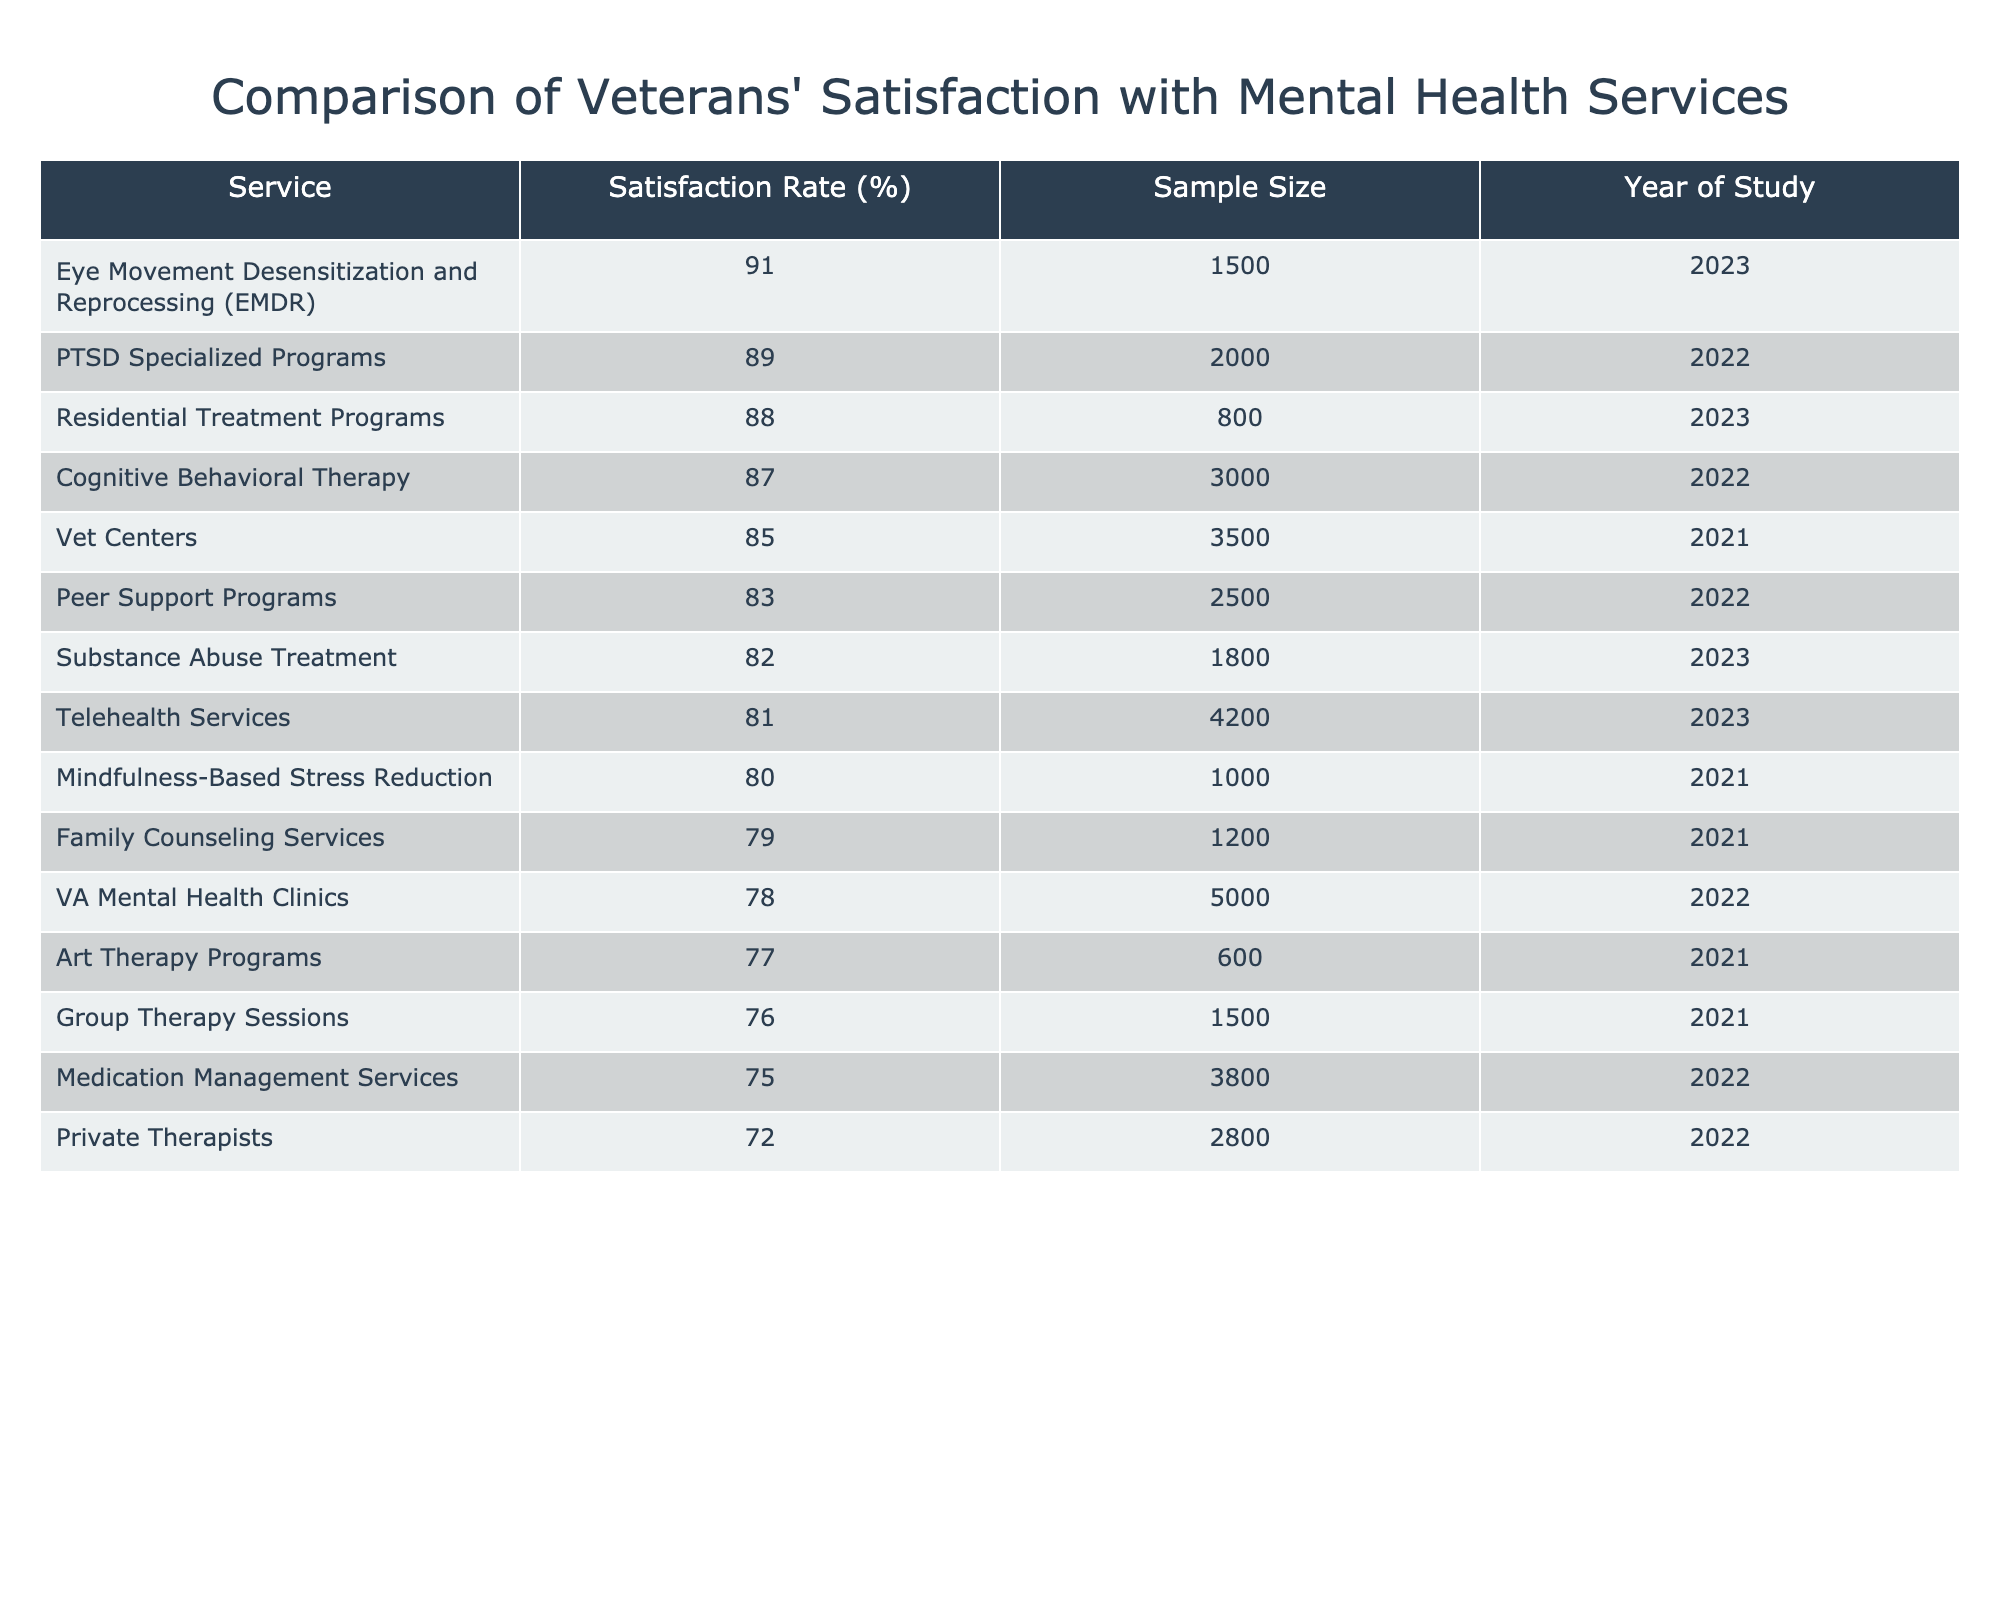What is the satisfaction rate for VA Mental Health Clinics? The satisfaction rate for VA Mental Health Clinics is listed directly in the table under the Satisfaction Rate (%) column, which shows 78%.
Answer: 78% Which mental health service has the highest satisfaction rate? Looking through the Satisfaction Rate (%) column, the highest value is 91%, which corresponds to Eye Movement Desensitization and Reprocessing (EMDR).
Answer: EMDR What is the average satisfaction rate for services with a sample size of 2000 or more? First, we need to identify the services with a sample size of 2000 or more: VA Mental Health Clinics (5000), Vet Centers (3500), Telehealth Services (4200), PTSD Specialized Programs (2000), Cognitive Behavioral Therapy (3000), and Residential Treatment Programs (800). The satisfaction rates for these services are 78%, 85%, 81%, 89%, 87%, and 88%. Adding these rates gives 78 + 85 + 81 + 89 + 87 + 88 = 508. Dividing this total by the number of services (6) gives 508 / 6 = 84.67%.
Answer: 84.67% Is the satisfaction rate for Substance Abuse Treatment above 80%? By checking the table, the satisfaction rate for Substance Abuse Treatment is 82%, which is above 80%.
Answer: Yes How does the satisfaction rate for Group Therapy Sessions compare to Private Therapists? The satisfaction rate for Group Therapy Sessions is 76% and for Private Therapists is 72%. Comparing these values, Group Therapy Sessions have a higher satisfaction rate than Private Therapists (76% > 72%).
Answer: Group Therapy Sessions have a higher rate What is the difference in satisfaction rate between PTSD Specialized Programs and Medication Management Services? The satisfaction rate for PTSD Specialized Programs is 89% and for Medication Management Services is 75%. To find the difference, subtract 75 from 89, which simplifies to 89 - 75 = 14%. Thus, PTSD Specialized Programs have a 14% higher satisfaction rate.
Answer: 14% Which services have a satisfaction rate of 80% or higher? Referring to the Satisfaction Rate (%) column, the services with 80% or higher satisfaction are: Vet Centers (85%), Telehealth Services (81%), PTSD Specialized Programs (89%), Cognitive Behavioral Therapy (87%), Eye Movement Desensitization and Reprocessing (EMDR) (91%), Substance Abuse Treatment (82%), Residential Treatment Programs (88%), Peer Support Programs (83%), and Mindfulness-Based Stress Reduction (80%). There are 9 services total.
Answer: 9 services What is the satisfaction rate for Family Counseling Services, and how does it compare to Art Therapy Programs? The satisfaction rate for Family Counseling Services is 79%, while for Art Therapy Programs, it is 77%. Comparing these, Family Counseling Services (79%) has a slightly higher satisfaction rate than Art Therapy Programs (77%).
Answer: Family Counseling Services is higher What mental health service has the lowest sample size, and what is its satisfaction rate? Checking the Sample Size column, the service with the lowest sample size is Mindfulness-Based Stress Reduction with 1000 participants. Its satisfaction rate, as noted in the Satisfaction Rate (%) column, is 80%.
Answer: Mindfulness-Based Stress Reduction, 80% 